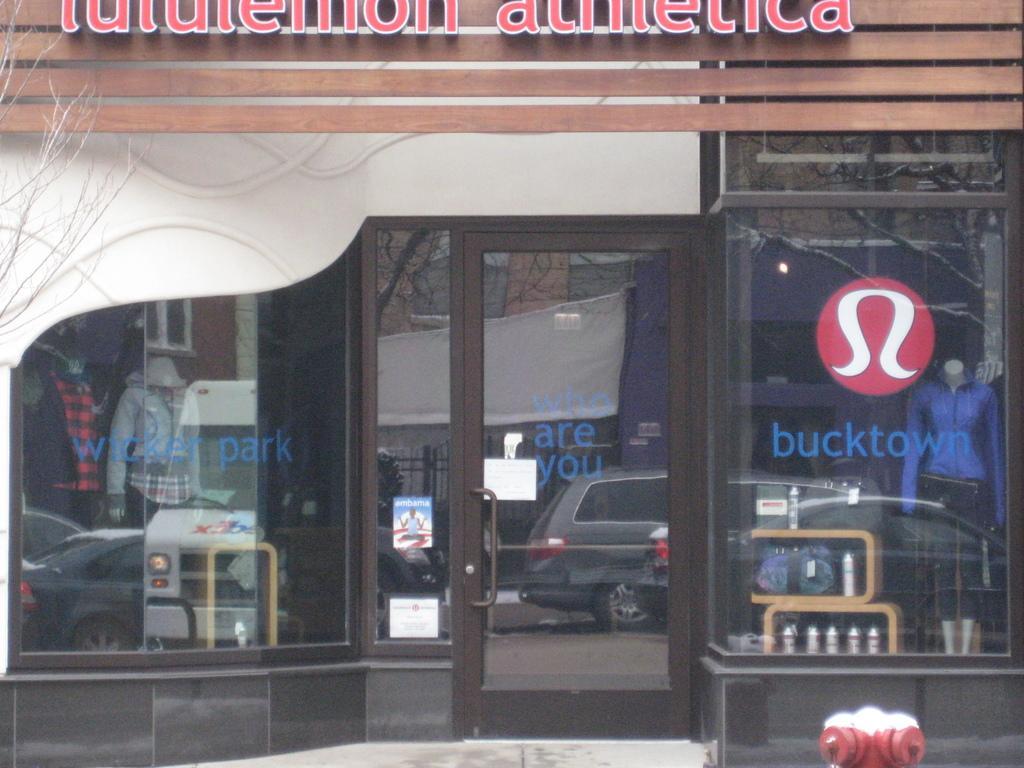Can you describe this image briefly? In the picture I can see glass walls, a glass door, vehicles, a fire hydrant, buildings, trees and some other objects. I can also see LED board on a wooden object and something written on the glass wall. 